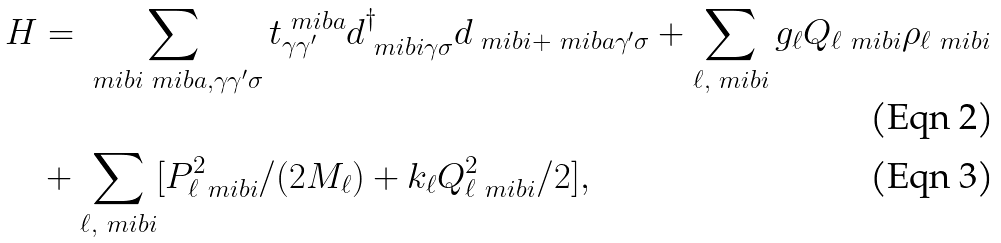Convert formula to latex. <formula><loc_0><loc_0><loc_500><loc_500>H & = \sum _ { \ m i b { i } \ m i b { a } , \gamma \gamma ^ { \prime } \sigma } t ^ { \ m i b { a } } _ { \gamma \gamma ^ { \prime } } d ^ { \dag } _ { \ m i b { i } \gamma \sigma } d _ { \ m i b { i } + \ m i b { a } \gamma ^ { \prime } \sigma } + \sum _ { \ell , \ m i b { i } } g _ { \ell } Q _ { \ell \ m i b { i } } \rho _ { \ell \ m i b { i } } \\ & + \sum _ { \ell , \ m i b { i } } [ P _ { \ell \ m i b { i } } ^ { 2 } / ( 2 M _ { \ell } ) + k _ { \ell } Q _ { \ell \ m i b { i } } ^ { 2 } / 2 ] ,</formula> 